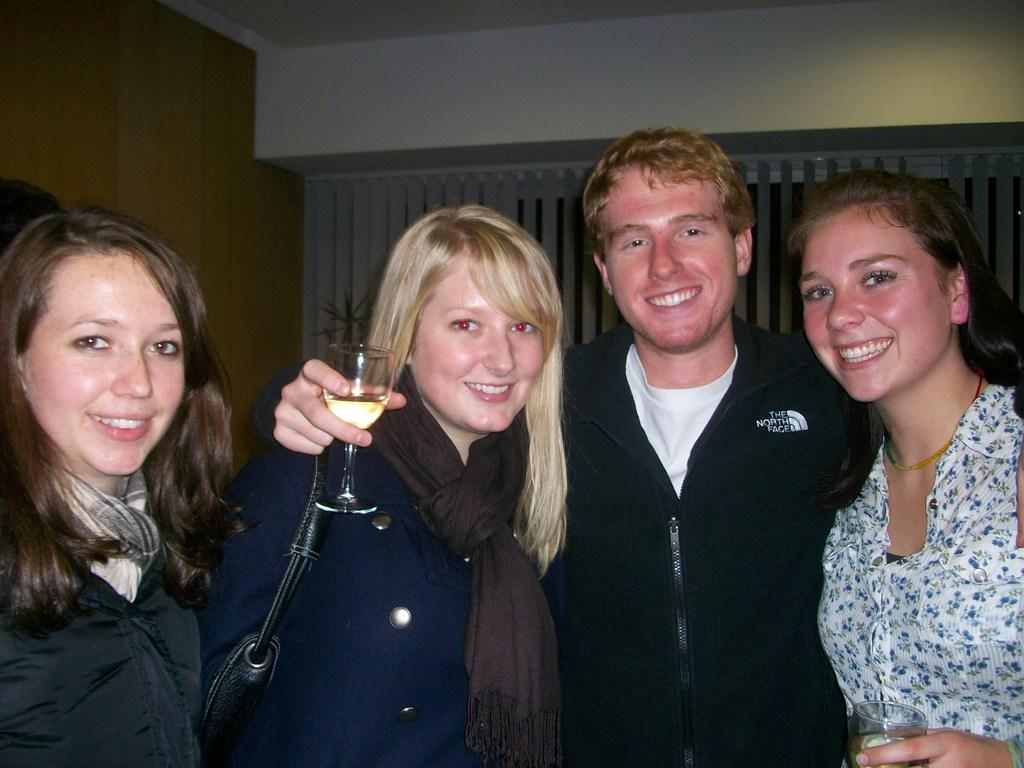How many people are present in the image? There are four people in the image. What is one person holding in the image? One person is holding a glass. What is another person wearing in the image? Another person is wearing a bag. What can be seen in the background of the image? There is a wall in the background of the image. What type of rhythm can be heard coming from the thing in the image? There is no thing present in the image that could produce a rhythm, and therefore no such sound can be heard. 